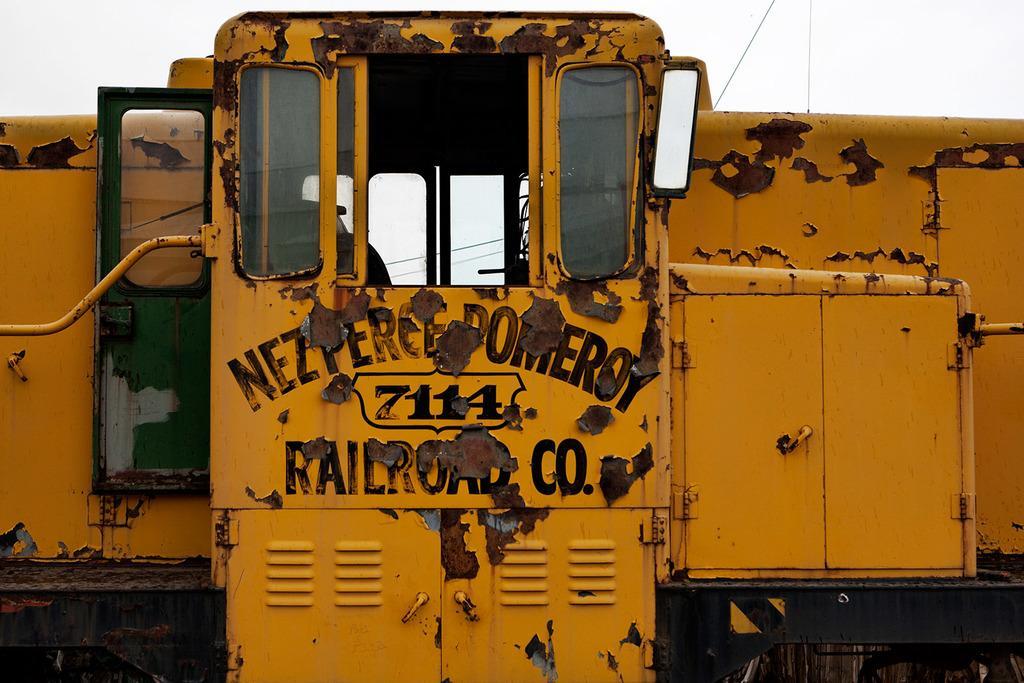Describe this image in one or two sentences. In this image I can see a train which is yellow and black in color and in the background I can see the sky. 